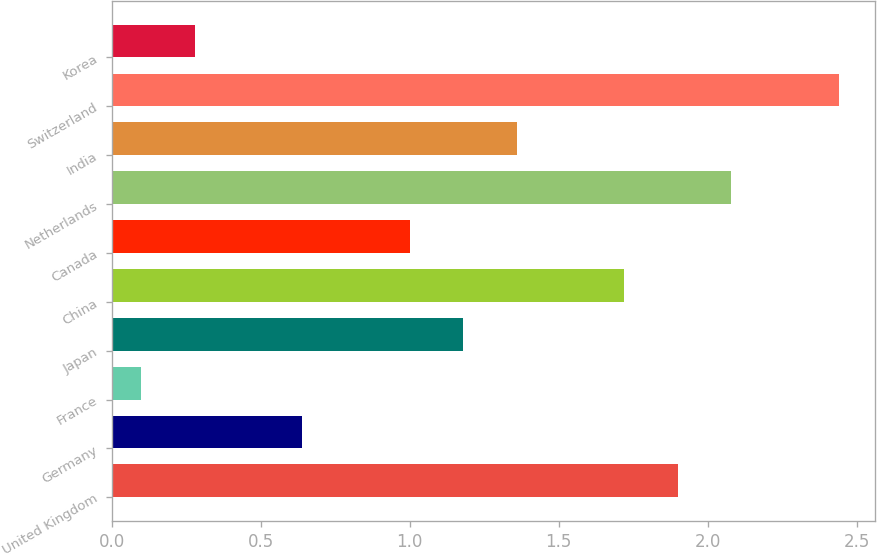Convert chart. <chart><loc_0><loc_0><loc_500><loc_500><bar_chart><fcel>United Kingdom<fcel>Germany<fcel>France<fcel>Japan<fcel>China<fcel>Canada<fcel>Netherlands<fcel>India<fcel>Switzerland<fcel>Korea<nl><fcel>1.9<fcel>0.64<fcel>0.1<fcel>1.18<fcel>1.72<fcel>1<fcel>2.08<fcel>1.36<fcel>2.44<fcel>0.28<nl></chart> 